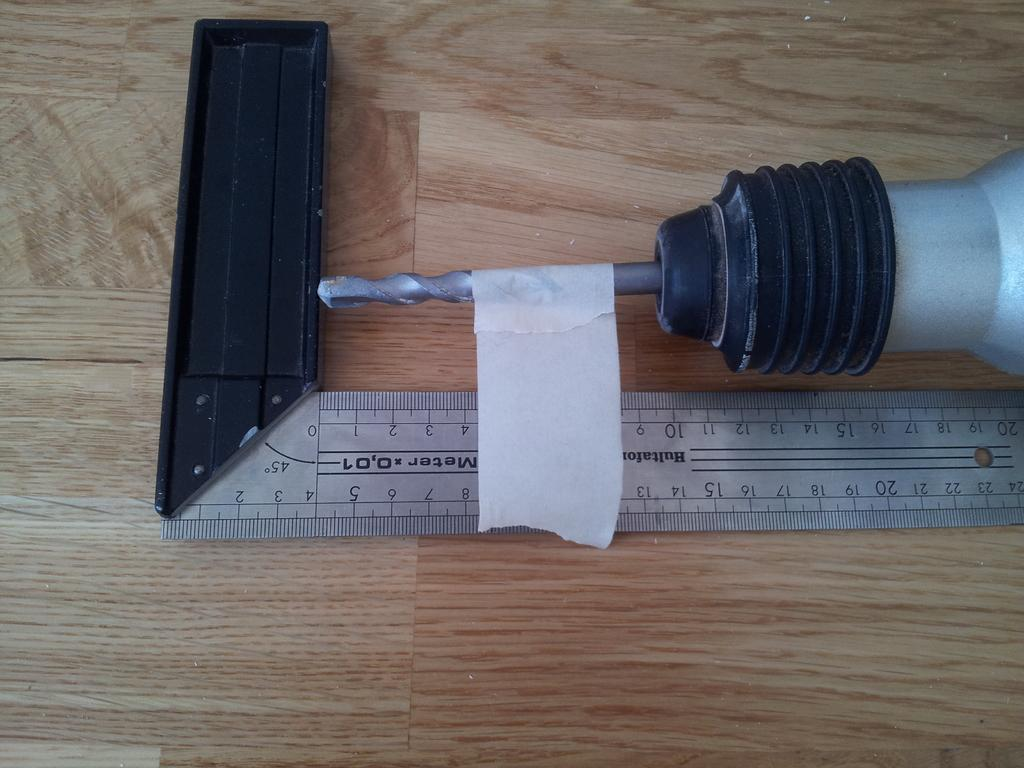Provide a one-sentence caption for the provided image. a ruler that says the number 45 on a section of it. 